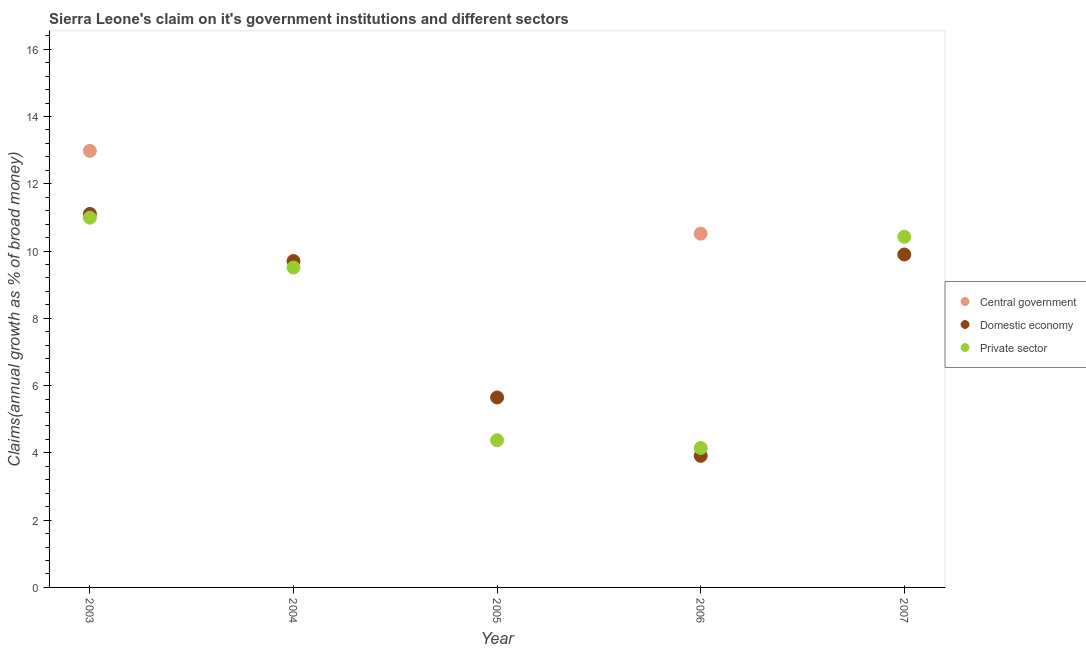Is the number of dotlines equal to the number of legend labels?
Give a very brief answer. No. What is the percentage of claim on the domestic economy in 2004?
Provide a short and direct response. 9.7. Across all years, what is the maximum percentage of claim on the domestic economy?
Your answer should be compact. 11.1. Across all years, what is the minimum percentage of claim on the private sector?
Provide a short and direct response. 4.14. What is the total percentage of claim on the domestic economy in the graph?
Your answer should be compact. 40.26. What is the difference between the percentage of claim on the domestic economy in 2004 and that in 2006?
Make the answer very short. 5.79. What is the difference between the percentage of claim on the private sector in 2003 and the percentage of claim on the domestic economy in 2005?
Provide a succinct answer. 5.34. What is the average percentage of claim on the private sector per year?
Give a very brief answer. 7.89. In the year 2006, what is the difference between the percentage of claim on the domestic economy and percentage of claim on the central government?
Ensure brevity in your answer.  -6.6. In how many years, is the percentage of claim on the central government greater than 14.4 %?
Your answer should be very brief. 0. What is the ratio of the percentage of claim on the private sector in 2003 to that in 2007?
Offer a very short reply. 1.05. Is the percentage of claim on the domestic economy in 2003 less than that in 2004?
Provide a short and direct response. No. What is the difference between the highest and the second highest percentage of claim on the private sector?
Ensure brevity in your answer.  0.57. What is the difference between the highest and the lowest percentage of claim on the private sector?
Provide a short and direct response. 6.85. Is the sum of the percentage of claim on the domestic economy in 2004 and 2006 greater than the maximum percentage of claim on the central government across all years?
Your response must be concise. Yes. Does the percentage of claim on the central government monotonically increase over the years?
Ensure brevity in your answer.  No. Is the percentage of claim on the central government strictly greater than the percentage of claim on the domestic economy over the years?
Ensure brevity in your answer.  No. What is the difference between two consecutive major ticks on the Y-axis?
Ensure brevity in your answer.  2. Does the graph contain grids?
Provide a short and direct response. No. Where does the legend appear in the graph?
Your answer should be very brief. Center right. How are the legend labels stacked?
Offer a very short reply. Vertical. What is the title of the graph?
Your answer should be compact. Sierra Leone's claim on it's government institutions and different sectors. What is the label or title of the X-axis?
Offer a terse response. Year. What is the label or title of the Y-axis?
Give a very brief answer. Claims(annual growth as % of broad money). What is the Claims(annual growth as % of broad money) in Central government in 2003?
Give a very brief answer. 12.98. What is the Claims(annual growth as % of broad money) of Domestic economy in 2003?
Ensure brevity in your answer.  11.1. What is the Claims(annual growth as % of broad money) in Private sector in 2003?
Give a very brief answer. 10.99. What is the Claims(annual growth as % of broad money) in Central government in 2004?
Keep it short and to the point. 0. What is the Claims(annual growth as % of broad money) of Domestic economy in 2004?
Give a very brief answer. 9.7. What is the Claims(annual growth as % of broad money) in Private sector in 2004?
Your answer should be very brief. 9.51. What is the Claims(annual growth as % of broad money) of Central government in 2005?
Your answer should be compact. 0. What is the Claims(annual growth as % of broad money) in Domestic economy in 2005?
Your response must be concise. 5.65. What is the Claims(annual growth as % of broad money) of Private sector in 2005?
Make the answer very short. 4.38. What is the Claims(annual growth as % of broad money) in Central government in 2006?
Provide a succinct answer. 10.52. What is the Claims(annual growth as % of broad money) of Domestic economy in 2006?
Give a very brief answer. 3.91. What is the Claims(annual growth as % of broad money) of Private sector in 2006?
Give a very brief answer. 4.14. What is the Claims(annual growth as % of broad money) of Domestic economy in 2007?
Give a very brief answer. 9.9. What is the Claims(annual growth as % of broad money) of Private sector in 2007?
Provide a short and direct response. 10.42. Across all years, what is the maximum Claims(annual growth as % of broad money) in Central government?
Offer a very short reply. 12.98. Across all years, what is the maximum Claims(annual growth as % of broad money) in Domestic economy?
Offer a terse response. 11.1. Across all years, what is the maximum Claims(annual growth as % of broad money) in Private sector?
Offer a very short reply. 10.99. Across all years, what is the minimum Claims(annual growth as % of broad money) in Central government?
Offer a terse response. 0. Across all years, what is the minimum Claims(annual growth as % of broad money) of Domestic economy?
Provide a succinct answer. 3.91. Across all years, what is the minimum Claims(annual growth as % of broad money) of Private sector?
Offer a terse response. 4.14. What is the total Claims(annual growth as % of broad money) in Central government in the graph?
Provide a short and direct response. 23.49. What is the total Claims(annual growth as % of broad money) in Domestic economy in the graph?
Offer a very short reply. 40.26. What is the total Claims(annual growth as % of broad money) of Private sector in the graph?
Make the answer very short. 39.44. What is the difference between the Claims(annual growth as % of broad money) in Domestic economy in 2003 and that in 2004?
Your response must be concise. 1.4. What is the difference between the Claims(annual growth as % of broad money) in Private sector in 2003 and that in 2004?
Offer a terse response. 1.48. What is the difference between the Claims(annual growth as % of broad money) of Domestic economy in 2003 and that in 2005?
Your answer should be very brief. 5.46. What is the difference between the Claims(annual growth as % of broad money) of Private sector in 2003 and that in 2005?
Offer a terse response. 6.62. What is the difference between the Claims(annual growth as % of broad money) in Central government in 2003 and that in 2006?
Keep it short and to the point. 2.46. What is the difference between the Claims(annual growth as % of broad money) of Domestic economy in 2003 and that in 2006?
Offer a very short reply. 7.19. What is the difference between the Claims(annual growth as % of broad money) of Private sector in 2003 and that in 2006?
Offer a very short reply. 6.85. What is the difference between the Claims(annual growth as % of broad money) of Domestic economy in 2003 and that in 2007?
Offer a very short reply. 1.21. What is the difference between the Claims(annual growth as % of broad money) in Private sector in 2003 and that in 2007?
Ensure brevity in your answer.  0.57. What is the difference between the Claims(annual growth as % of broad money) of Domestic economy in 2004 and that in 2005?
Provide a succinct answer. 4.06. What is the difference between the Claims(annual growth as % of broad money) of Private sector in 2004 and that in 2005?
Offer a terse response. 5.13. What is the difference between the Claims(annual growth as % of broad money) in Domestic economy in 2004 and that in 2006?
Offer a terse response. 5.79. What is the difference between the Claims(annual growth as % of broad money) in Private sector in 2004 and that in 2006?
Your response must be concise. 5.37. What is the difference between the Claims(annual growth as % of broad money) in Domestic economy in 2004 and that in 2007?
Make the answer very short. -0.19. What is the difference between the Claims(annual growth as % of broad money) of Private sector in 2004 and that in 2007?
Make the answer very short. -0.91. What is the difference between the Claims(annual growth as % of broad money) in Domestic economy in 2005 and that in 2006?
Provide a short and direct response. 1.74. What is the difference between the Claims(annual growth as % of broad money) of Private sector in 2005 and that in 2006?
Your response must be concise. 0.23. What is the difference between the Claims(annual growth as % of broad money) of Domestic economy in 2005 and that in 2007?
Make the answer very short. -4.25. What is the difference between the Claims(annual growth as % of broad money) of Private sector in 2005 and that in 2007?
Make the answer very short. -6.05. What is the difference between the Claims(annual growth as % of broad money) of Domestic economy in 2006 and that in 2007?
Ensure brevity in your answer.  -5.99. What is the difference between the Claims(annual growth as % of broad money) of Private sector in 2006 and that in 2007?
Ensure brevity in your answer.  -6.28. What is the difference between the Claims(annual growth as % of broad money) in Central government in 2003 and the Claims(annual growth as % of broad money) in Domestic economy in 2004?
Offer a terse response. 3.27. What is the difference between the Claims(annual growth as % of broad money) in Central government in 2003 and the Claims(annual growth as % of broad money) in Private sector in 2004?
Provide a short and direct response. 3.47. What is the difference between the Claims(annual growth as % of broad money) in Domestic economy in 2003 and the Claims(annual growth as % of broad money) in Private sector in 2004?
Your response must be concise. 1.59. What is the difference between the Claims(annual growth as % of broad money) in Central government in 2003 and the Claims(annual growth as % of broad money) in Domestic economy in 2005?
Provide a short and direct response. 7.33. What is the difference between the Claims(annual growth as % of broad money) in Central government in 2003 and the Claims(annual growth as % of broad money) in Private sector in 2005?
Offer a terse response. 8.6. What is the difference between the Claims(annual growth as % of broad money) of Domestic economy in 2003 and the Claims(annual growth as % of broad money) of Private sector in 2005?
Keep it short and to the point. 6.73. What is the difference between the Claims(annual growth as % of broad money) of Central government in 2003 and the Claims(annual growth as % of broad money) of Domestic economy in 2006?
Make the answer very short. 9.07. What is the difference between the Claims(annual growth as % of broad money) of Central government in 2003 and the Claims(annual growth as % of broad money) of Private sector in 2006?
Provide a succinct answer. 8.83. What is the difference between the Claims(annual growth as % of broad money) of Domestic economy in 2003 and the Claims(annual growth as % of broad money) of Private sector in 2006?
Provide a succinct answer. 6.96. What is the difference between the Claims(annual growth as % of broad money) in Central government in 2003 and the Claims(annual growth as % of broad money) in Domestic economy in 2007?
Make the answer very short. 3.08. What is the difference between the Claims(annual growth as % of broad money) of Central government in 2003 and the Claims(annual growth as % of broad money) of Private sector in 2007?
Give a very brief answer. 2.55. What is the difference between the Claims(annual growth as % of broad money) of Domestic economy in 2003 and the Claims(annual growth as % of broad money) of Private sector in 2007?
Ensure brevity in your answer.  0.68. What is the difference between the Claims(annual growth as % of broad money) of Domestic economy in 2004 and the Claims(annual growth as % of broad money) of Private sector in 2005?
Your response must be concise. 5.33. What is the difference between the Claims(annual growth as % of broad money) of Domestic economy in 2004 and the Claims(annual growth as % of broad money) of Private sector in 2006?
Ensure brevity in your answer.  5.56. What is the difference between the Claims(annual growth as % of broad money) in Domestic economy in 2004 and the Claims(annual growth as % of broad money) in Private sector in 2007?
Provide a succinct answer. -0.72. What is the difference between the Claims(annual growth as % of broad money) of Domestic economy in 2005 and the Claims(annual growth as % of broad money) of Private sector in 2006?
Give a very brief answer. 1.5. What is the difference between the Claims(annual growth as % of broad money) of Domestic economy in 2005 and the Claims(annual growth as % of broad money) of Private sector in 2007?
Your answer should be compact. -4.78. What is the difference between the Claims(annual growth as % of broad money) in Central government in 2006 and the Claims(annual growth as % of broad money) in Domestic economy in 2007?
Give a very brief answer. 0.62. What is the difference between the Claims(annual growth as % of broad money) in Central government in 2006 and the Claims(annual growth as % of broad money) in Private sector in 2007?
Provide a short and direct response. 0.09. What is the difference between the Claims(annual growth as % of broad money) in Domestic economy in 2006 and the Claims(annual growth as % of broad money) in Private sector in 2007?
Offer a very short reply. -6.51. What is the average Claims(annual growth as % of broad money) of Central government per year?
Make the answer very short. 4.7. What is the average Claims(annual growth as % of broad money) in Domestic economy per year?
Keep it short and to the point. 8.05. What is the average Claims(annual growth as % of broad money) of Private sector per year?
Keep it short and to the point. 7.89. In the year 2003, what is the difference between the Claims(annual growth as % of broad money) in Central government and Claims(annual growth as % of broad money) in Domestic economy?
Offer a terse response. 1.87. In the year 2003, what is the difference between the Claims(annual growth as % of broad money) of Central government and Claims(annual growth as % of broad money) of Private sector?
Keep it short and to the point. 1.99. In the year 2003, what is the difference between the Claims(annual growth as % of broad money) of Domestic economy and Claims(annual growth as % of broad money) of Private sector?
Provide a succinct answer. 0.11. In the year 2004, what is the difference between the Claims(annual growth as % of broad money) of Domestic economy and Claims(annual growth as % of broad money) of Private sector?
Your answer should be very brief. 0.19. In the year 2005, what is the difference between the Claims(annual growth as % of broad money) in Domestic economy and Claims(annual growth as % of broad money) in Private sector?
Offer a very short reply. 1.27. In the year 2006, what is the difference between the Claims(annual growth as % of broad money) of Central government and Claims(annual growth as % of broad money) of Domestic economy?
Offer a very short reply. 6.6. In the year 2006, what is the difference between the Claims(annual growth as % of broad money) in Central government and Claims(annual growth as % of broad money) in Private sector?
Your answer should be very brief. 6.37. In the year 2006, what is the difference between the Claims(annual growth as % of broad money) of Domestic economy and Claims(annual growth as % of broad money) of Private sector?
Ensure brevity in your answer.  -0.23. In the year 2007, what is the difference between the Claims(annual growth as % of broad money) of Domestic economy and Claims(annual growth as % of broad money) of Private sector?
Offer a terse response. -0.53. What is the ratio of the Claims(annual growth as % of broad money) in Domestic economy in 2003 to that in 2004?
Provide a succinct answer. 1.14. What is the ratio of the Claims(annual growth as % of broad money) of Private sector in 2003 to that in 2004?
Your response must be concise. 1.16. What is the ratio of the Claims(annual growth as % of broad money) in Domestic economy in 2003 to that in 2005?
Keep it short and to the point. 1.97. What is the ratio of the Claims(annual growth as % of broad money) in Private sector in 2003 to that in 2005?
Ensure brevity in your answer.  2.51. What is the ratio of the Claims(annual growth as % of broad money) in Central government in 2003 to that in 2006?
Provide a short and direct response. 1.23. What is the ratio of the Claims(annual growth as % of broad money) of Domestic economy in 2003 to that in 2006?
Provide a succinct answer. 2.84. What is the ratio of the Claims(annual growth as % of broad money) of Private sector in 2003 to that in 2006?
Your response must be concise. 2.65. What is the ratio of the Claims(annual growth as % of broad money) in Domestic economy in 2003 to that in 2007?
Your response must be concise. 1.12. What is the ratio of the Claims(annual growth as % of broad money) in Private sector in 2003 to that in 2007?
Make the answer very short. 1.05. What is the ratio of the Claims(annual growth as % of broad money) in Domestic economy in 2004 to that in 2005?
Make the answer very short. 1.72. What is the ratio of the Claims(annual growth as % of broad money) in Private sector in 2004 to that in 2005?
Make the answer very short. 2.17. What is the ratio of the Claims(annual growth as % of broad money) of Domestic economy in 2004 to that in 2006?
Your response must be concise. 2.48. What is the ratio of the Claims(annual growth as % of broad money) in Private sector in 2004 to that in 2006?
Give a very brief answer. 2.29. What is the ratio of the Claims(annual growth as % of broad money) in Domestic economy in 2004 to that in 2007?
Offer a terse response. 0.98. What is the ratio of the Claims(annual growth as % of broad money) of Private sector in 2004 to that in 2007?
Your answer should be compact. 0.91. What is the ratio of the Claims(annual growth as % of broad money) in Domestic economy in 2005 to that in 2006?
Offer a very short reply. 1.44. What is the ratio of the Claims(annual growth as % of broad money) of Private sector in 2005 to that in 2006?
Your response must be concise. 1.06. What is the ratio of the Claims(annual growth as % of broad money) of Domestic economy in 2005 to that in 2007?
Provide a short and direct response. 0.57. What is the ratio of the Claims(annual growth as % of broad money) of Private sector in 2005 to that in 2007?
Your answer should be compact. 0.42. What is the ratio of the Claims(annual growth as % of broad money) in Domestic economy in 2006 to that in 2007?
Offer a terse response. 0.4. What is the ratio of the Claims(annual growth as % of broad money) of Private sector in 2006 to that in 2007?
Keep it short and to the point. 0.4. What is the difference between the highest and the second highest Claims(annual growth as % of broad money) in Domestic economy?
Your response must be concise. 1.21. What is the difference between the highest and the second highest Claims(annual growth as % of broad money) in Private sector?
Provide a succinct answer. 0.57. What is the difference between the highest and the lowest Claims(annual growth as % of broad money) of Central government?
Ensure brevity in your answer.  12.98. What is the difference between the highest and the lowest Claims(annual growth as % of broad money) of Domestic economy?
Offer a terse response. 7.19. What is the difference between the highest and the lowest Claims(annual growth as % of broad money) in Private sector?
Your response must be concise. 6.85. 